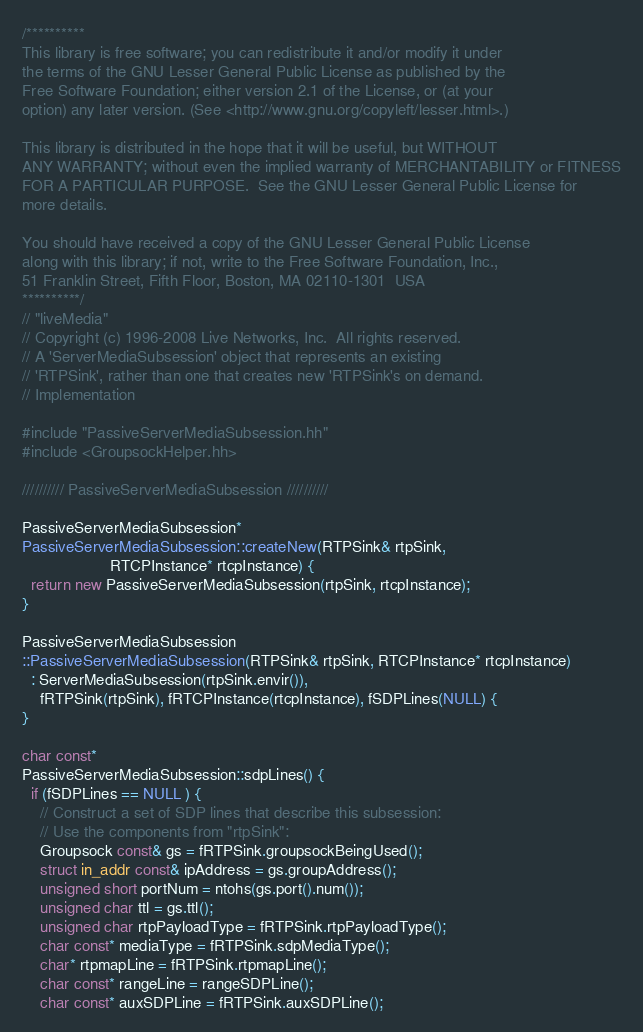<code> <loc_0><loc_0><loc_500><loc_500><_C++_>/**********
This library is free software; you can redistribute it and/or modify it under
the terms of the GNU Lesser General Public License as published by the
Free Software Foundation; either version 2.1 of the License, or (at your
option) any later version. (See <http://www.gnu.org/copyleft/lesser.html>.)

This library is distributed in the hope that it will be useful, but WITHOUT
ANY WARRANTY; without even the implied warranty of MERCHANTABILITY or FITNESS
FOR A PARTICULAR PURPOSE.  See the GNU Lesser General Public License for
more details.

You should have received a copy of the GNU Lesser General Public License
along with this library; if not, write to the Free Software Foundation, Inc.,
51 Franklin Street, Fifth Floor, Boston, MA 02110-1301  USA
**********/
// "liveMedia"
// Copyright (c) 1996-2008 Live Networks, Inc.  All rights reserved.
// A 'ServerMediaSubsession' object that represents an existing
// 'RTPSink', rather than one that creates new 'RTPSink's on demand.
// Implementation

#include "PassiveServerMediaSubsession.hh"
#include <GroupsockHelper.hh>

////////// PassiveServerMediaSubsession //////////

PassiveServerMediaSubsession*
PassiveServerMediaSubsession::createNew(RTPSink& rtpSink,
					RTCPInstance* rtcpInstance) {
  return new PassiveServerMediaSubsession(rtpSink, rtcpInstance);
}

PassiveServerMediaSubsession
::PassiveServerMediaSubsession(RTPSink& rtpSink, RTCPInstance* rtcpInstance)
  : ServerMediaSubsession(rtpSink.envir()),
    fRTPSink(rtpSink), fRTCPInstance(rtcpInstance), fSDPLines(NULL) {
}

char const*
PassiveServerMediaSubsession::sdpLines() {
  if (fSDPLines == NULL ) {
    // Construct a set of SDP lines that describe this subsession:
    // Use the components from "rtpSink":
    Groupsock const& gs = fRTPSink.groupsockBeingUsed();
    struct in_addr const& ipAddress = gs.groupAddress();
    unsigned short portNum = ntohs(gs.port().num());
    unsigned char ttl = gs.ttl();
    unsigned char rtpPayloadType = fRTPSink.rtpPayloadType();
    char const* mediaType = fRTPSink.sdpMediaType();
    char* rtpmapLine = fRTPSink.rtpmapLine();
    char const* rangeLine = rangeSDPLine();
    char const* auxSDPLine = fRTPSink.auxSDPLine();</code> 